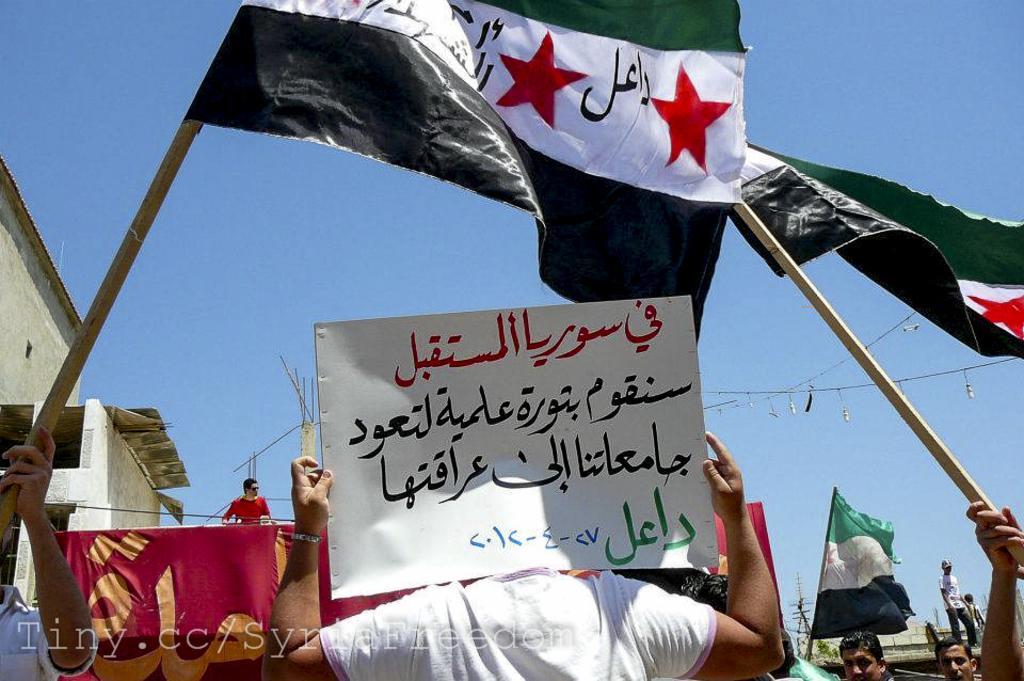Can you describe this image briefly? In the center of the image we can see a person is holding a board. At the bottom of the image we can see some persons are holding flags, some text, buildings, tower, wires are there. At the top of the image sky is there. In the middle of the image pillars, rods are there. 